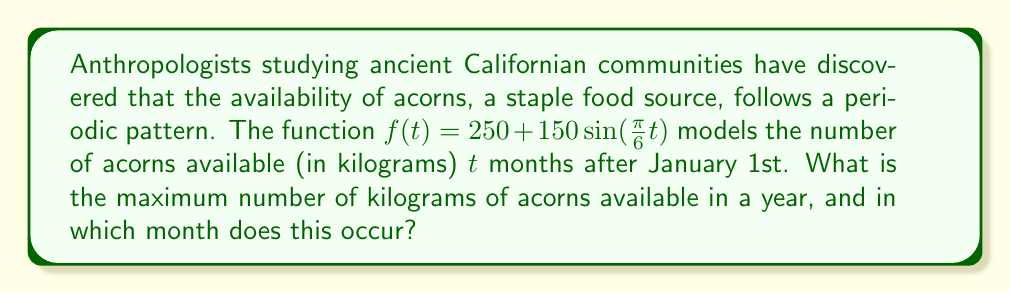Help me with this question. To solve this problem, we'll follow these steps:

1) The function $f(t) = 250 + 150\sin(\frac{\pi}{6}t)$ is a sinusoidal function.
   - 250 is the midline (average value)
   - 150 is the amplitude (maximum deviation from the midline)

2) The maximum value of a sine function is 1, which occurs when the angle is $\frac{\pi}{2}$ (or 90°).

3) To find the maximum value of $f(t)$:
   $f_{max} = 250 + 150 = 400$ kg

4) To find when this maximum occurs, we need to solve:
   $\frac{\pi}{6}t = \frac{\pi}{2}$

5) Solving for $t$:
   $t = \frac{\pi}{2} \div \frac{\pi}{6} = 3$

6) This means the maximum occurs 3 months after January 1st, which is April.

Therefore, the maximum number of kilograms of acorns available is 400 kg, occurring in April.
Answer: 400 kg in April 